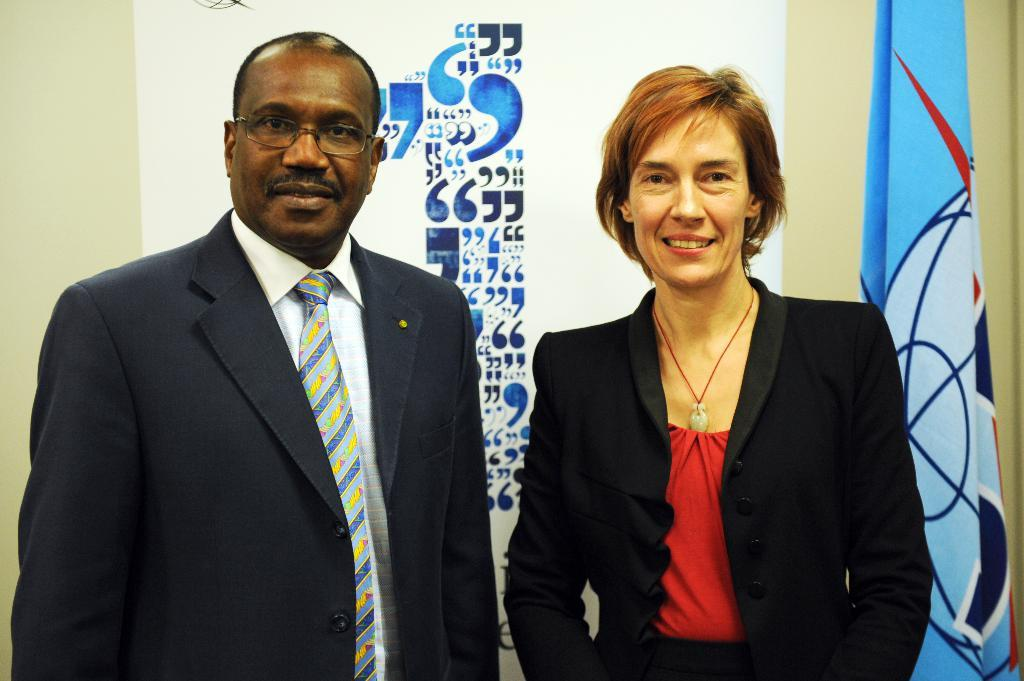Who are the people in the image? There is a man and a woman in the image. Where are the man and woman located in the image? The man and woman are in the center of the image. What can be seen in the background of the image? There is a flag and a poster in the background of the image. What type of pie is being served to the man and woman in the image? There is no pie present in the image; it features a man and a woman in the center with a flag and a poster in the background. 